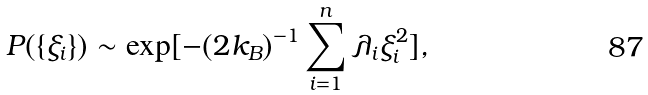Convert formula to latex. <formula><loc_0><loc_0><loc_500><loc_500>P ( \{ \xi _ { i } \} ) \sim \exp [ - ( 2 k _ { B } ) ^ { - 1 } \sum ^ { n } _ { i = 1 } \lambda _ { i } \xi ^ { 2 } _ { i } ] ,</formula> 